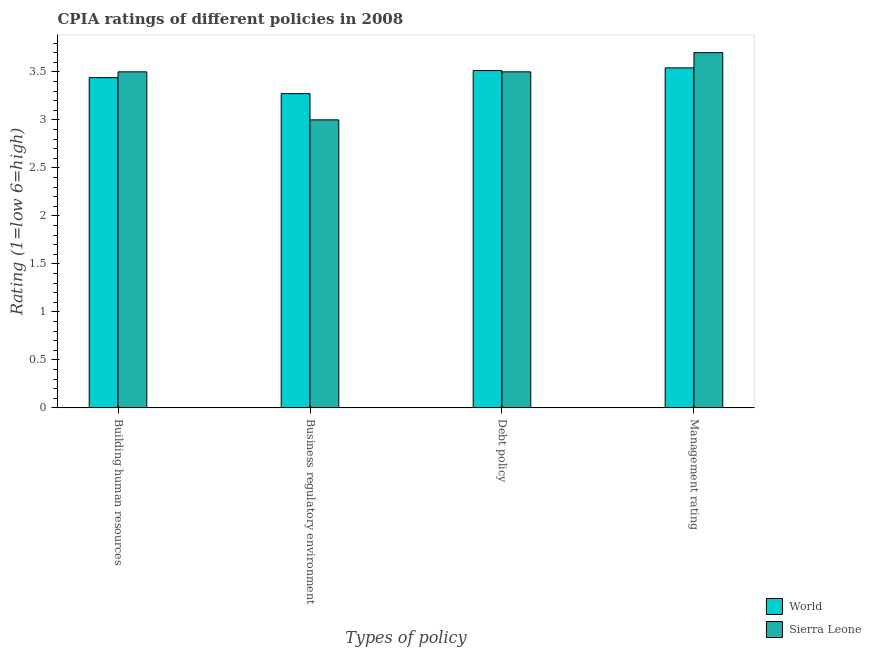What is the label of the 3rd group of bars from the left?
Keep it short and to the point. Debt policy. What is the cpia rating of business regulatory environment in Sierra Leone?
Your answer should be very brief. 3. Across all countries, what is the maximum cpia rating of business regulatory environment?
Your answer should be compact. 3.27. Across all countries, what is the minimum cpia rating of management?
Your answer should be very brief. 3.54. In which country was the cpia rating of building human resources maximum?
Offer a very short reply. Sierra Leone. In which country was the cpia rating of debt policy minimum?
Make the answer very short. Sierra Leone. What is the total cpia rating of management in the graph?
Offer a very short reply. 7.24. What is the difference between the cpia rating of building human resources in Sierra Leone and that in World?
Your answer should be very brief. 0.06. What is the difference between the cpia rating of building human resources in Sierra Leone and the cpia rating of management in World?
Your answer should be very brief. -0.04. What is the average cpia rating of debt policy per country?
Ensure brevity in your answer.  3.51. What is the difference between the cpia rating of business regulatory environment and cpia rating of debt policy in World?
Give a very brief answer. -0.24. In how many countries, is the cpia rating of management greater than 0.6 ?
Your answer should be compact. 2. What is the ratio of the cpia rating of business regulatory environment in Sierra Leone to that in World?
Keep it short and to the point. 0.92. What is the difference between the highest and the second highest cpia rating of debt policy?
Offer a very short reply. 0.01. What is the difference between the highest and the lowest cpia rating of business regulatory environment?
Ensure brevity in your answer.  0.27. In how many countries, is the cpia rating of business regulatory environment greater than the average cpia rating of business regulatory environment taken over all countries?
Offer a very short reply. 1. Is the sum of the cpia rating of debt policy in Sierra Leone and World greater than the maximum cpia rating of management across all countries?
Offer a very short reply. Yes. Is it the case that in every country, the sum of the cpia rating of building human resources and cpia rating of debt policy is greater than the sum of cpia rating of management and cpia rating of business regulatory environment?
Provide a succinct answer. No. What does the 2nd bar from the left in Debt policy represents?
Offer a very short reply. Sierra Leone. What does the 1st bar from the right in Management rating represents?
Offer a terse response. Sierra Leone. Are all the bars in the graph horizontal?
Make the answer very short. No. What is the difference between two consecutive major ticks on the Y-axis?
Offer a terse response. 0.5. Are the values on the major ticks of Y-axis written in scientific E-notation?
Your answer should be very brief. No. Does the graph contain any zero values?
Your response must be concise. No. Does the graph contain grids?
Offer a very short reply. No. Where does the legend appear in the graph?
Give a very brief answer. Bottom right. What is the title of the graph?
Provide a short and direct response. CPIA ratings of different policies in 2008. What is the label or title of the X-axis?
Give a very brief answer. Types of policy. What is the Rating (1=low 6=high) of World in Building human resources?
Ensure brevity in your answer.  3.44. What is the Rating (1=low 6=high) in World in Business regulatory environment?
Make the answer very short. 3.27. What is the Rating (1=low 6=high) in World in Debt policy?
Keep it short and to the point. 3.51. What is the Rating (1=low 6=high) of World in Management rating?
Your answer should be compact. 3.54. Across all Types of policy, what is the maximum Rating (1=low 6=high) in World?
Offer a terse response. 3.54. Across all Types of policy, what is the maximum Rating (1=low 6=high) of Sierra Leone?
Keep it short and to the point. 3.7. Across all Types of policy, what is the minimum Rating (1=low 6=high) in World?
Give a very brief answer. 3.27. Across all Types of policy, what is the minimum Rating (1=low 6=high) in Sierra Leone?
Your answer should be compact. 3. What is the total Rating (1=low 6=high) of World in the graph?
Keep it short and to the point. 13.77. What is the difference between the Rating (1=low 6=high) of World in Building human resources and that in Business regulatory environment?
Your response must be concise. 0.17. What is the difference between the Rating (1=low 6=high) of World in Building human resources and that in Debt policy?
Ensure brevity in your answer.  -0.07. What is the difference between the Rating (1=low 6=high) in Sierra Leone in Building human resources and that in Debt policy?
Offer a terse response. 0. What is the difference between the Rating (1=low 6=high) in World in Building human resources and that in Management rating?
Provide a short and direct response. -0.1. What is the difference between the Rating (1=low 6=high) of Sierra Leone in Building human resources and that in Management rating?
Provide a short and direct response. -0.2. What is the difference between the Rating (1=low 6=high) of World in Business regulatory environment and that in Debt policy?
Offer a terse response. -0.24. What is the difference between the Rating (1=low 6=high) in World in Business regulatory environment and that in Management rating?
Your answer should be very brief. -0.27. What is the difference between the Rating (1=low 6=high) of Sierra Leone in Business regulatory environment and that in Management rating?
Make the answer very short. -0.7. What is the difference between the Rating (1=low 6=high) in World in Debt policy and that in Management rating?
Offer a very short reply. -0.03. What is the difference between the Rating (1=low 6=high) in Sierra Leone in Debt policy and that in Management rating?
Your answer should be compact. -0.2. What is the difference between the Rating (1=low 6=high) of World in Building human resources and the Rating (1=low 6=high) of Sierra Leone in Business regulatory environment?
Give a very brief answer. 0.44. What is the difference between the Rating (1=low 6=high) of World in Building human resources and the Rating (1=low 6=high) of Sierra Leone in Debt policy?
Your answer should be compact. -0.06. What is the difference between the Rating (1=low 6=high) in World in Building human resources and the Rating (1=low 6=high) in Sierra Leone in Management rating?
Your answer should be compact. -0.26. What is the difference between the Rating (1=low 6=high) in World in Business regulatory environment and the Rating (1=low 6=high) in Sierra Leone in Debt policy?
Provide a succinct answer. -0.23. What is the difference between the Rating (1=low 6=high) in World in Business regulatory environment and the Rating (1=low 6=high) in Sierra Leone in Management rating?
Your response must be concise. -0.43. What is the difference between the Rating (1=low 6=high) of World in Debt policy and the Rating (1=low 6=high) of Sierra Leone in Management rating?
Provide a succinct answer. -0.19. What is the average Rating (1=low 6=high) in World per Types of policy?
Provide a short and direct response. 3.44. What is the average Rating (1=low 6=high) of Sierra Leone per Types of policy?
Provide a short and direct response. 3.42. What is the difference between the Rating (1=low 6=high) of World and Rating (1=low 6=high) of Sierra Leone in Building human resources?
Give a very brief answer. -0.06. What is the difference between the Rating (1=low 6=high) in World and Rating (1=low 6=high) in Sierra Leone in Business regulatory environment?
Your answer should be very brief. 0.27. What is the difference between the Rating (1=low 6=high) in World and Rating (1=low 6=high) in Sierra Leone in Debt policy?
Provide a short and direct response. 0.01. What is the difference between the Rating (1=low 6=high) of World and Rating (1=low 6=high) of Sierra Leone in Management rating?
Give a very brief answer. -0.16. What is the ratio of the Rating (1=low 6=high) of World in Building human resources to that in Business regulatory environment?
Give a very brief answer. 1.05. What is the ratio of the Rating (1=low 6=high) in World in Building human resources to that in Debt policy?
Ensure brevity in your answer.  0.98. What is the ratio of the Rating (1=low 6=high) of Sierra Leone in Building human resources to that in Debt policy?
Make the answer very short. 1. What is the ratio of the Rating (1=low 6=high) of World in Building human resources to that in Management rating?
Your response must be concise. 0.97. What is the ratio of the Rating (1=low 6=high) in Sierra Leone in Building human resources to that in Management rating?
Provide a short and direct response. 0.95. What is the ratio of the Rating (1=low 6=high) of World in Business regulatory environment to that in Debt policy?
Provide a succinct answer. 0.93. What is the ratio of the Rating (1=low 6=high) in Sierra Leone in Business regulatory environment to that in Debt policy?
Offer a terse response. 0.86. What is the ratio of the Rating (1=low 6=high) in World in Business regulatory environment to that in Management rating?
Your answer should be compact. 0.92. What is the ratio of the Rating (1=low 6=high) of Sierra Leone in Business regulatory environment to that in Management rating?
Provide a short and direct response. 0.81. What is the ratio of the Rating (1=low 6=high) of World in Debt policy to that in Management rating?
Ensure brevity in your answer.  0.99. What is the ratio of the Rating (1=low 6=high) in Sierra Leone in Debt policy to that in Management rating?
Your answer should be very brief. 0.95. What is the difference between the highest and the second highest Rating (1=low 6=high) of World?
Give a very brief answer. 0.03. What is the difference between the highest and the second highest Rating (1=low 6=high) in Sierra Leone?
Provide a succinct answer. 0.2. What is the difference between the highest and the lowest Rating (1=low 6=high) in World?
Your answer should be very brief. 0.27. 